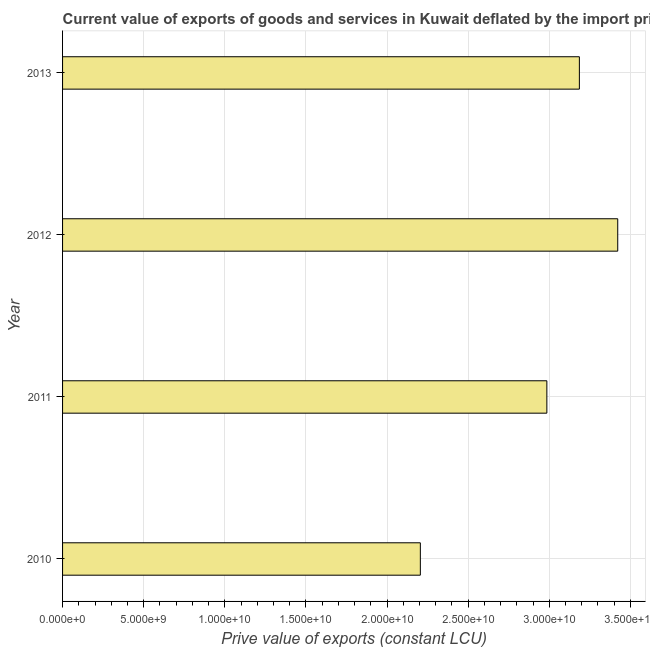Does the graph contain grids?
Provide a short and direct response. Yes. What is the title of the graph?
Give a very brief answer. Current value of exports of goods and services in Kuwait deflated by the import price index. What is the label or title of the X-axis?
Offer a very short reply. Prive value of exports (constant LCU). What is the label or title of the Y-axis?
Offer a very short reply. Year. What is the price value of exports in 2011?
Offer a terse response. 2.99e+1. Across all years, what is the maximum price value of exports?
Offer a very short reply. 3.42e+1. Across all years, what is the minimum price value of exports?
Offer a terse response. 2.21e+1. In which year was the price value of exports minimum?
Make the answer very short. 2010. What is the sum of the price value of exports?
Make the answer very short. 1.18e+11. What is the difference between the price value of exports in 2011 and 2012?
Give a very brief answer. -4.37e+09. What is the average price value of exports per year?
Give a very brief answer. 2.95e+1. What is the median price value of exports?
Give a very brief answer. 3.09e+1. In how many years, is the price value of exports greater than 31000000000 LCU?
Your answer should be compact. 2. What is the ratio of the price value of exports in 2010 to that in 2012?
Ensure brevity in your answer.  0.64. Is the price value of exports in 2010 less than that in 2012?
Your response must be concise. Yes. What is the difference between the highest and the second highest price value of exports?
Give a very brief answer. 2.36e+09. Is the sum of the price value of exports in 2011 and 2013 greater than the maximum price value of exports across all years?
Make the answer very short. Yes. What is the difference between the highest and the lowest price value of exports?
Offer a very short reply. 1.22e+1. In how many years, is the price value of exports greater than the average price value of exports taken over all years?
Your response must be concise. 3. How many bars are there?
Offer a terse response. 4. How many years are there in the graph?
Give a very brief answer. 4. What is the difference between two consecutive major ticks on the X-axis?
Your response must be concise. 5.00e+09. What is the Prive value of exports (constant LCU) in 2010?
Offer a terse response. 2.21e+1. What is the Prive value of exports (constant LCU) of 2011?
Your answer should be compact. 2.99e+1. What is the Prive value of exports (constant LCU) of 2012?
Provide a short and direct response. 3.42e+1. What is the Prive value of exports (constant LCU) in 2013?
Make the answer very short. 3.19e+1. What is the difference between the Prive value of exports (constant LCU) in 2010 and 2011?
Ensure brevity in your answer.  -7.80e+09. What is the difference between the Prive value of exports (constant LCU) in 2010 and 2012?
Keep it short and to the point. -1.22e+1. What is the difference between the Prive value of exports (constant LCU) in 2010 and 2013?
Offer a terse response. -9.80e+09. What is the difference between the Prive value of exports (constant LCU) in 2011 and 2012?
Offer a terse response. -4.37e+09. What is the difference between the Prive value of exports (constant LCU) in 2011 and 2013?
Your answer should be compact. -2.00e+09. What is the difference between the Prive value of exports (constant LCU) in 2012 and 2013?
Give a very brief answer. 2.36e+09. What is the ratio of the Prive value of exports (constant LCU) in 2010 to that in 2011?
Your answer should be compact. 0.74. What is the ratio of the Prive value of exports (constant LCU) in 2010 to that in 2012?
Your answer should be compact. 0.64. What is the ratio of the Prive value of exports (constant LCU) in 2010 to that in 2013?
Ensure brevity in your answer.  0.69. What is the ratio of the Prive value of exports (constant LCU) in 2011 to that in 2012?
Provide a succinct answer. 0.87. What is the ratio of the Prive value of exports (constant LCU) in 2011 to that in 2013?
Provide a short and direct response. 0.94. What is the ratio of the Prive value of exports (constant LCU) in 2012 to that in 2013?
Provide a short and direct response. 1.07. 